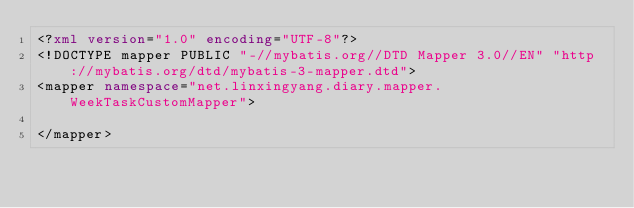Convert code to text. <code><loc_0><loc_0><loc_500><loc_500><_XML_><?xml version="1.0" encoding="UTF-8"?><!DOCTYPE mapper PUBLIC "-//mybatis.org//DTD Mapper 3.0//EN" "http://mybatis.org/dtd/mybatis-3-mapper.dtd"><mapper namespace="net.linxingyang.diary.mapper.WeekTaskCustomMapper"></mapper></code> 